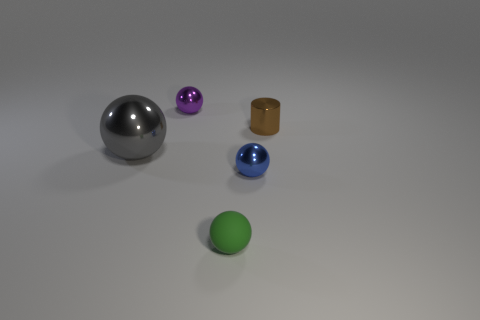Subtract all purple shiny spheres. How many spheres are left? 3 Add 3 small purple metal cubes. How many objects exist? 8 Subtract 1 balls. How many balls are left? 3 Subtract all green balls. How many balls are left? 3 Add 3 tiny cylinders. How many tiny cylinders are left? 4 Add 4 tiny green rubber things. How many tiny green rubber things exist? 5 Subtract 0 blue cubes. How many objects are left? 5 Subtract all balls. How many objects are left? 1 Subtract all green cylinders. Subtract all cyan balls. How many cylinders are left? 1 Subtract all brown cylinders. Subtract all tiny purple shiny spheres. How many objects are left? 3 